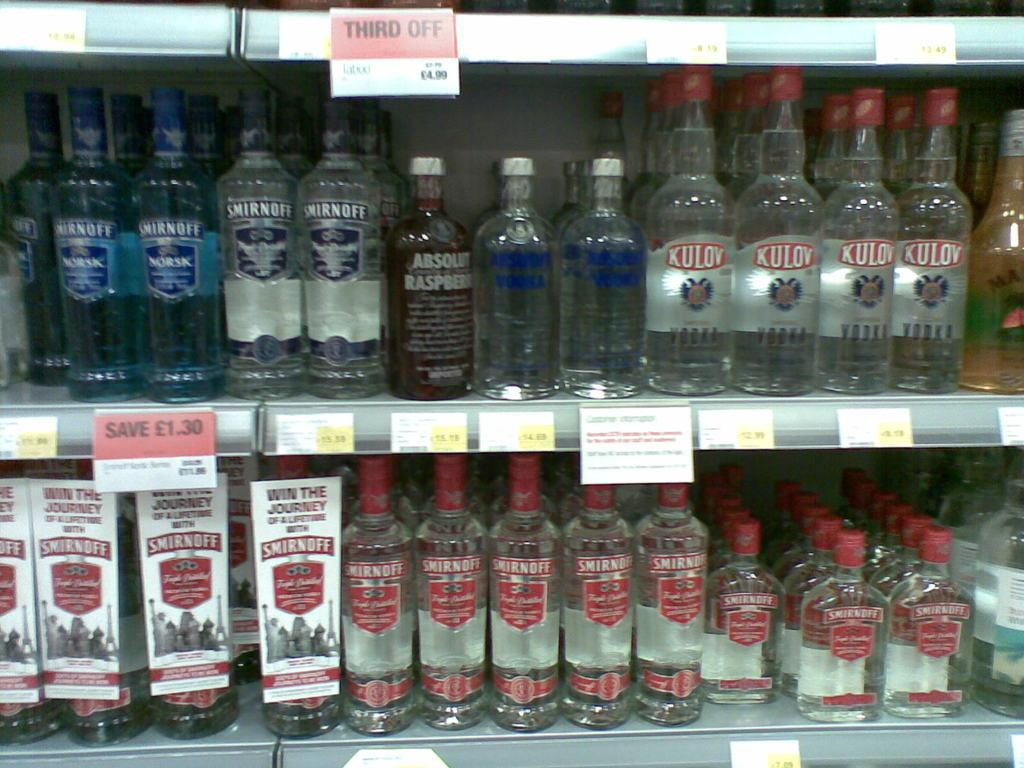<image>
Present a compact description of the photo's key features. Two shelves filled with glass alcoholic bottles of Smirnoff, Absolute and Kulov brands. 